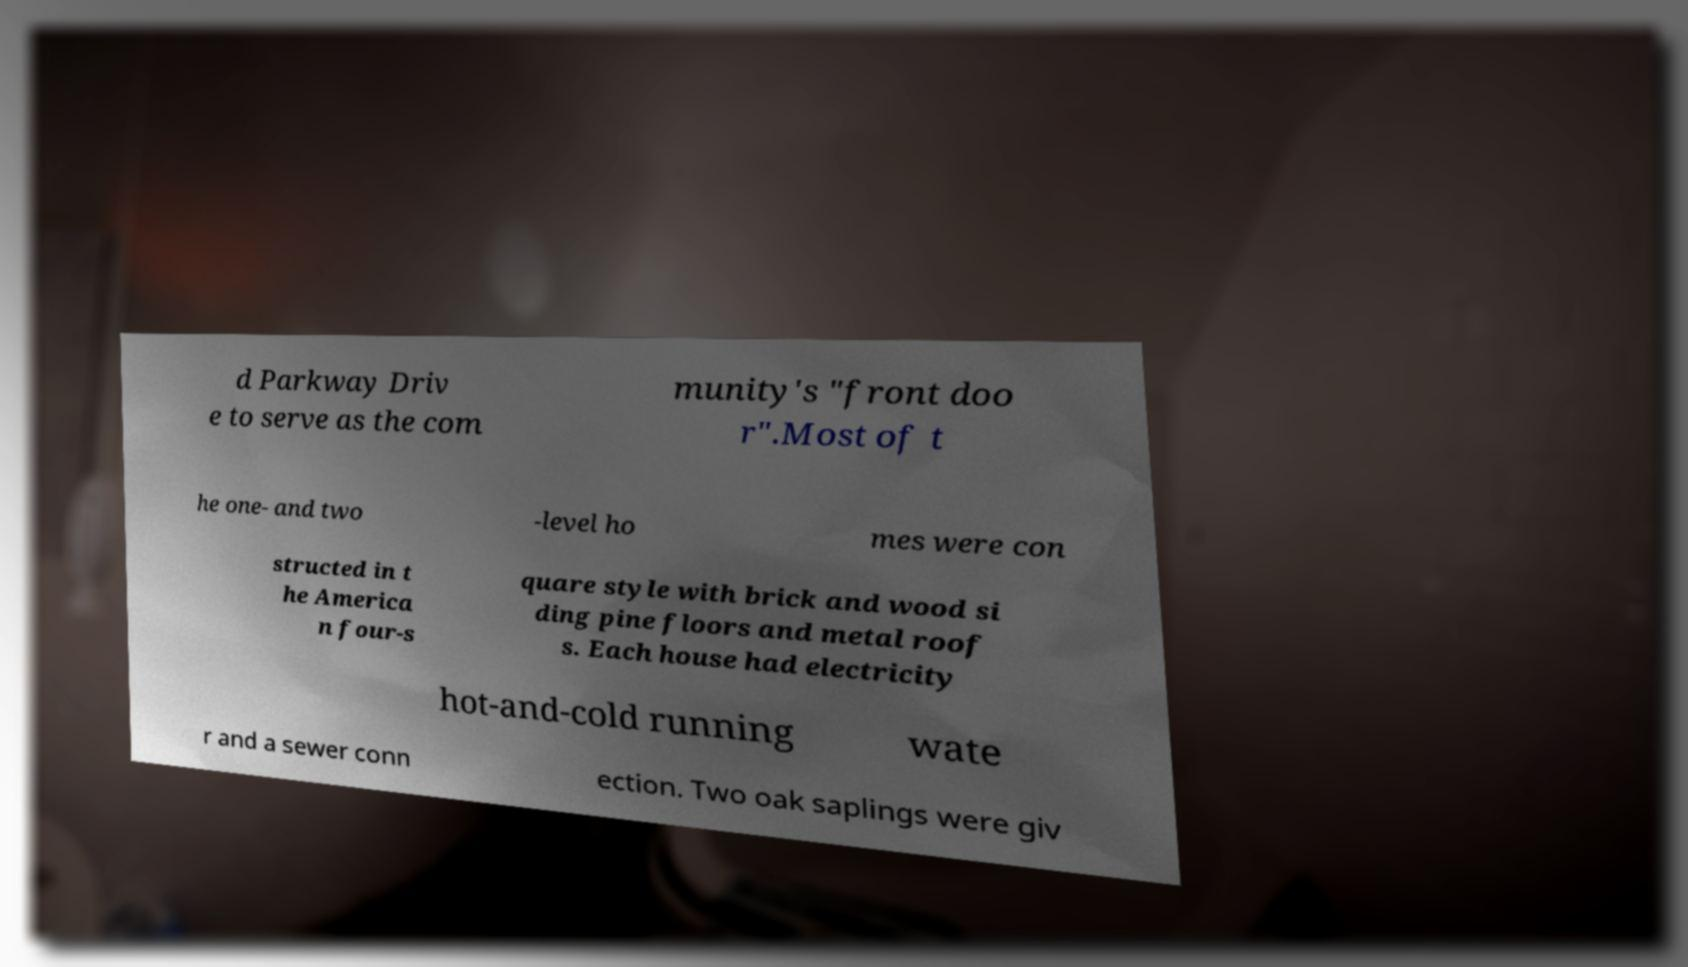What messages or text are displayed in this image? I need them in a readable, typed format. d Parkway Driv e to serve as the com munity's "front doo r".Most of t he one- and two -level ho mes were con structed in t he America n four-s quare style with brick and wood si ding pine floors and metal roof s. Each house had electricity hot-and-cold running wate r and a sewer conn ection. Two oak saplings were giv 